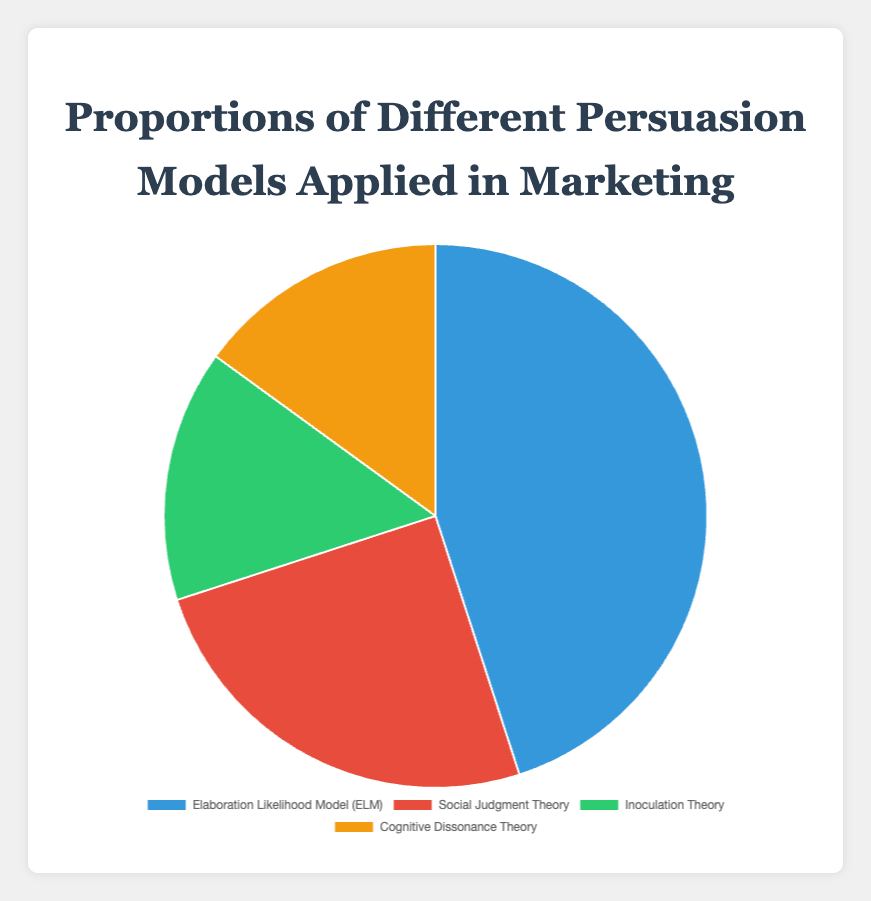What percentage of the pie chart is represented by the Elaboration Likelihood Model (ELM)? The figure shows that the Elaboration Likelihood Model (ELM) occupies 45% of the pie chart. This value is indicated in the data provided and visually represented by the portion of the pie chart labeled as ELM.
Answer: 45% Which two persuasion models have the same percentage, and what is that percentage? By examining the pie chart, we can see that Inoculation Theory and Cognitive Dissonance Theory each cover the same segment size, corresponding to 15% each as indicated in the data.
Answer: Inoculation Theory and Cognitive Dissonance Theory, 15% What is the combined percentage of the Social Judgment Theory and Inoculation Theory? The pie chart indicates that Social Judgment Theory holds 25% and Inoculation Theory has 15%. Adding these two percentages together yields 25% + 15% = 40%.
Answer: 40% Which persuasion model is depicted by the green section of the pie chart? The visual representation of the pie chart shows that the green section is associated with Inoculation Theory, as per the color legend provided in the figure.
Answer: Inoculation Theory Which persuasion model accounts for the largest share of the pie chart? Observing the pie chart, the Elaboration Likelihood Model (ELM) occupies the largest segment at 45%, which is the highest percentage among the provided models.
Answer: Elaboration Likelihood Model (ELM) By how many percentage points does the Elaboration Likelihood Model (ELM) exceed the Social Judgment Theory? The percentage for the Elaboration Likelihood Model (ELM) is 45%, while the Social Judgment Theory is 25%. The difference between these two values is 45% - 25% = 20%.
Answer: 20% What is the total percentage represented by all the persuasion models in the chart? This is a pie chart where the total percentage is always 100% since it represents the whole distribution of the data.
Answer: 100% If we were to group Inoculation Theory and Cognitive Dissonance Theory together, what would their combined percentage be, and would they outnumber Social Judgment Theory? Adding the percentages for Inoculation Theory (15%) and Cognitive Dissonance Theory (15%) gives us a combined total of 30%. Comparing this to Social Judgment Theory's 25%, yes, they would collectively outnumber Social Judgment Theory by 5%.
Answer: 30%, Yes 